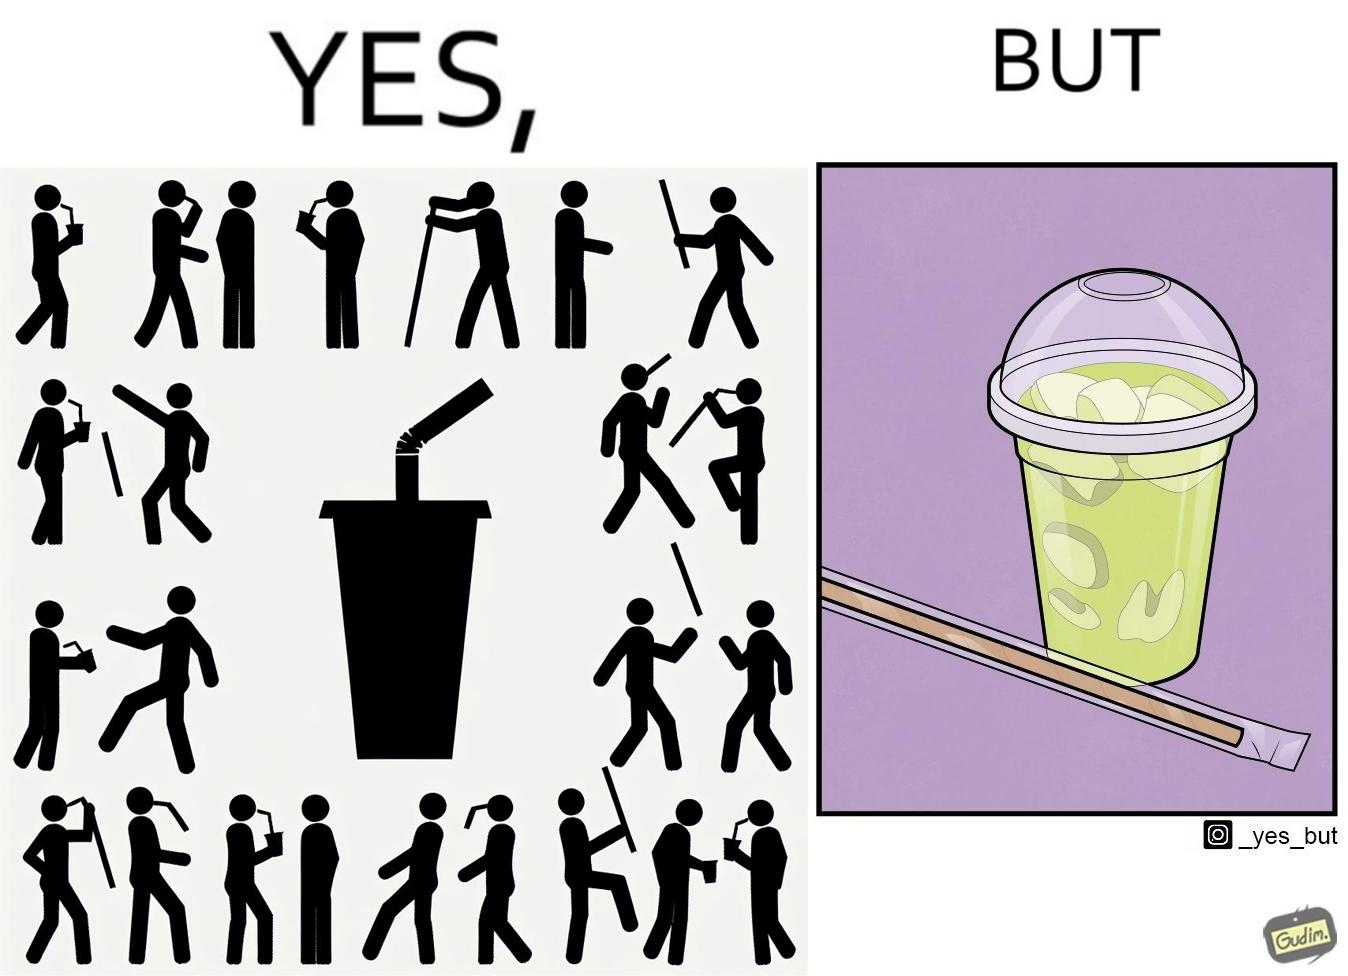What is shown in the left half versus the right half of this image? In the left part of the image: It is a paper straw In the right part of the image: It is paper straw in a plastic covering and a soft drink in a plastic cup 